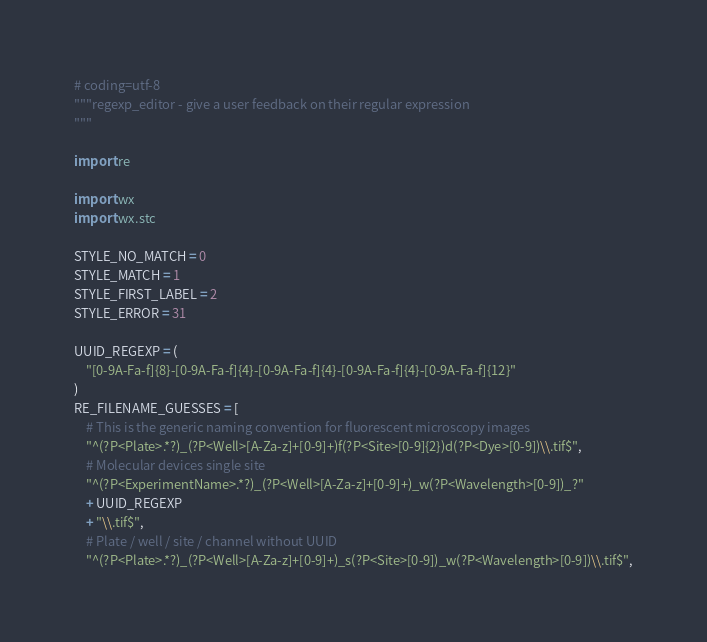Convert code to text. <code><loc_0><loc_0><loc_500><loc_500><_Python_># coding=utf-8
"""regexp_editor - give a user feedback on their regular expression
"""

import re

import wx
import wx.stc

STYLE_NO_MATCH = 0
STYLE_MATCH = 1
STYLE_FIRST_LABEL = 2
STYLE_ERROR = 31

UUID_REGEXP = (
    "[0-9A-Fa-f]{8}-[0-9A-Fa-f]{4}-[0-9A-Fa-f]{4}-[0-9A-Fa-f]{4}-[0-9A-Fa-f]{12}"
)
RE_FILENAME_GUESSES = [
    # This is the generic naming convention for fluorescent microscopy images
    "^(?P<Plate>.*?)_(?P<Well>[A-Za-z]+[0-9]+)f(?P<Site>[0-9]{2})d(?P<Dye>[0-9])\\.tif$",
    # Molecular devices single site
    "^(?P<ExperimentName>.*?)_(?P<Well>[A-Za-z]+[0-9]+)_w(?P<Wavelength>[0-9])_?"
    + UUID_REGEXP
    + "\\.tif$",
    # Plate / well / site / channel without UUID
    "^(?P<Plate>.*?)_(?P<Well>[A-Za-z]+[0-9]+)_s(?P<Site>[0-9])_w(?P<Wavelength>[0-9])\\.tif$",</code> 